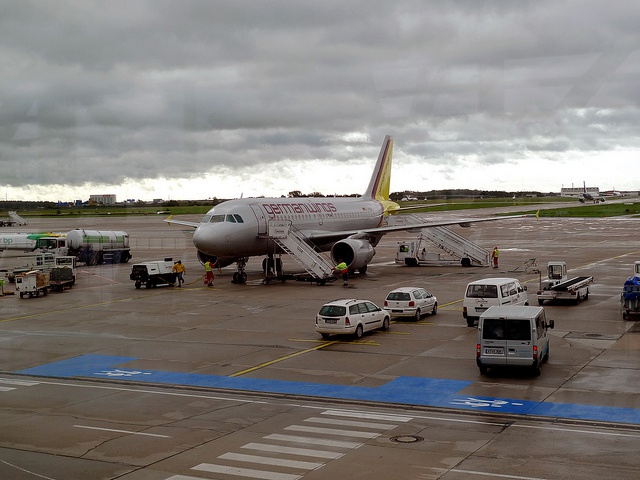Describe the objects in this image and their specific colors. I can see airplane in darkgray, gray, and black tones, truck in darkgray, black, and gray tones, truck in darkgray, black, gray, and darkgreen tones, car in darkgray, black, and gray tones, and car in darkgray, black, and gray tones in this image. 